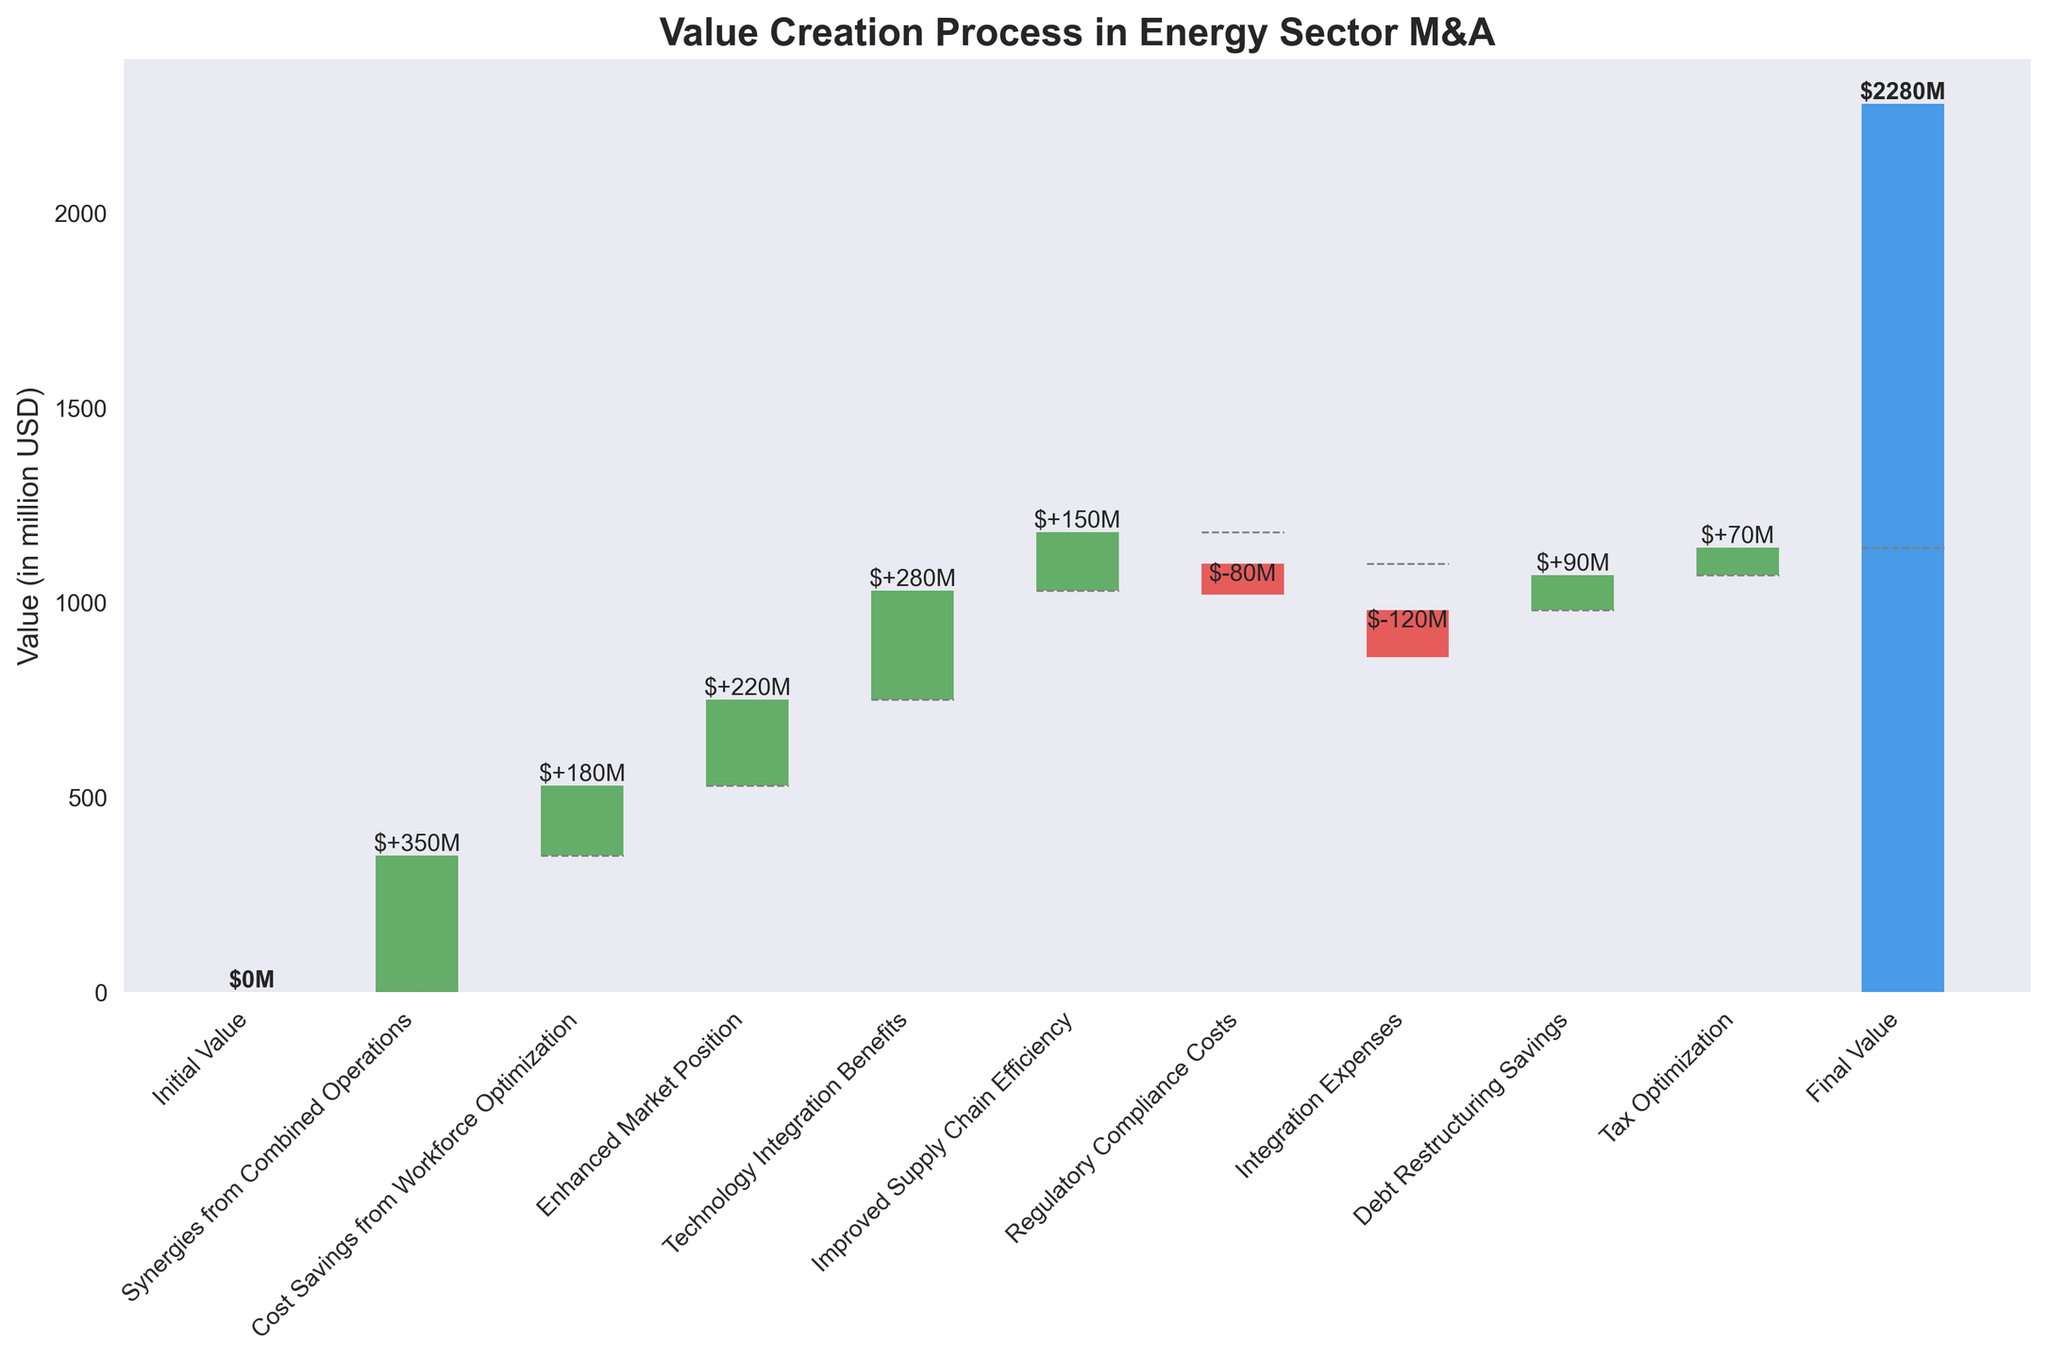what is the title of the figure? The title of the figure is written at the top of the chart.
Answer: Value Creation Process in Energy Sector M&A What is the value associated with 'Synergies from Combined Operations'? The value of each step is indicated by bars in the chart. Look at the bar labeled 'Synergies from Combined Operations'.
Answer: 350 million USD Which step has a negative impact on the final value? Steps with negative impacts are represented with red bars. Look for red bars and check their labels.
Answer: Regulatory Compliance Costs, Integration Expenses How much value is added by 'Cost Savings from Workforce Optimization' and 'Improved Supply Chain Efficiency' combined? Sum the values of the two steps: 180 million USD from 'Cost Savings from Workforce Optimization' and 150 million USD from 'Improved Supply Chain Efficiency'.
Answer: 330 million USD What is the final value achieved after all steps are accounted for? The final value is shown at the end of the cumulative sequence in the chart, explicitly labeled as 'Final Value'.
Answer: 1140 million USD What is the initial value before any steps are taken? The initial value is the starting point of the chart, labeled as 'Initial Value'.
Answer: 0 million USD Compare the value added by 'Technology Integration Benefits' and 'Tax Optimization'. Which is higher? Compare the values of 'Technology Integration Benefits' (280 million USD) and 'Tax Optimization' (70 million USD).
Answer: Technology Integration Benefits How much total value do the positive contributions add to the final value? Sum all the positive values from the individual steps: 350+180+220+280+150+90+70 = 1340 million USD.
Answer: 1340 million USD How much are the total deductions from the final value due to negative impacts? Sum all negative values from the individual steps: -80 + -120 = -200 million USD.
Answer: 200 million USD in deductions What value is added by 'Debt Restructuring Savings'? Identify the bar labeled 'Debt Restructuring Savings' and read the value.
Answer: 90 million USD 